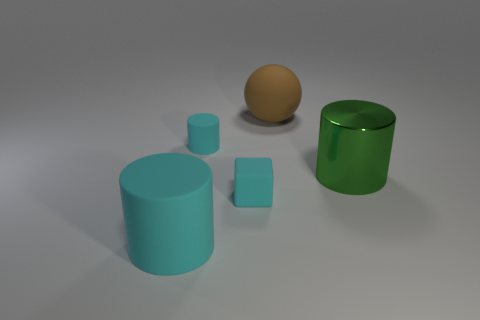Is there any other thing that has the same material as the green cylinder?
Keep it short and to the point. No. Is there any other thing that has the same shape as the big brown matte thing?
Keep it short and to the point. No. How many tiny rubber objects are the same color as the small cylinder?
Your answer should be compact. 1. There is another rubber cylinder that is the same color as the large matte cylinder; what is its size?
Offer a terse response. Small. Is there another large thing that has the same material as the large brown thing?
Keep it short and to the point. Yes. What is the small cyan object behind the large metal cylinder made of?
Your answer should be very brief. Rubber. There is a tiny rubber thing that is in front of the big metallic object; is its color the same as the cylinder that is in front of the shiny cylinder?
Offer a terse response. Yes. There is a matte object that is the same size as the ball; what color is it?
Give a very brief answer. Cyan. What number of other objects are the same shape as the big shiny thing?
Provide a succinct answer. 2. How big is the cylinder that is in front of the large green metal object?
Your response must be concise. Large. 